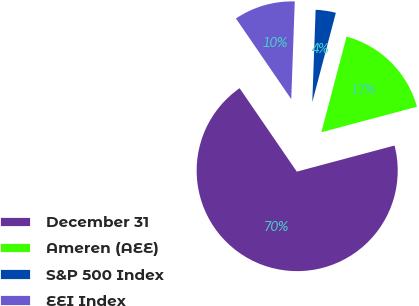Convert chart to OTSL. <chart><loc_0><loc_0><loc_500><loc_500><pie_chart><fcel>December 31<fcel>Ameren (AEE)<fcel>S&P 500 Index<fcel>EEI Index<nl><fcel>69.58%<fcel>16.74%<fcel>3.53%<fcel>10.14%<nl></chart> 